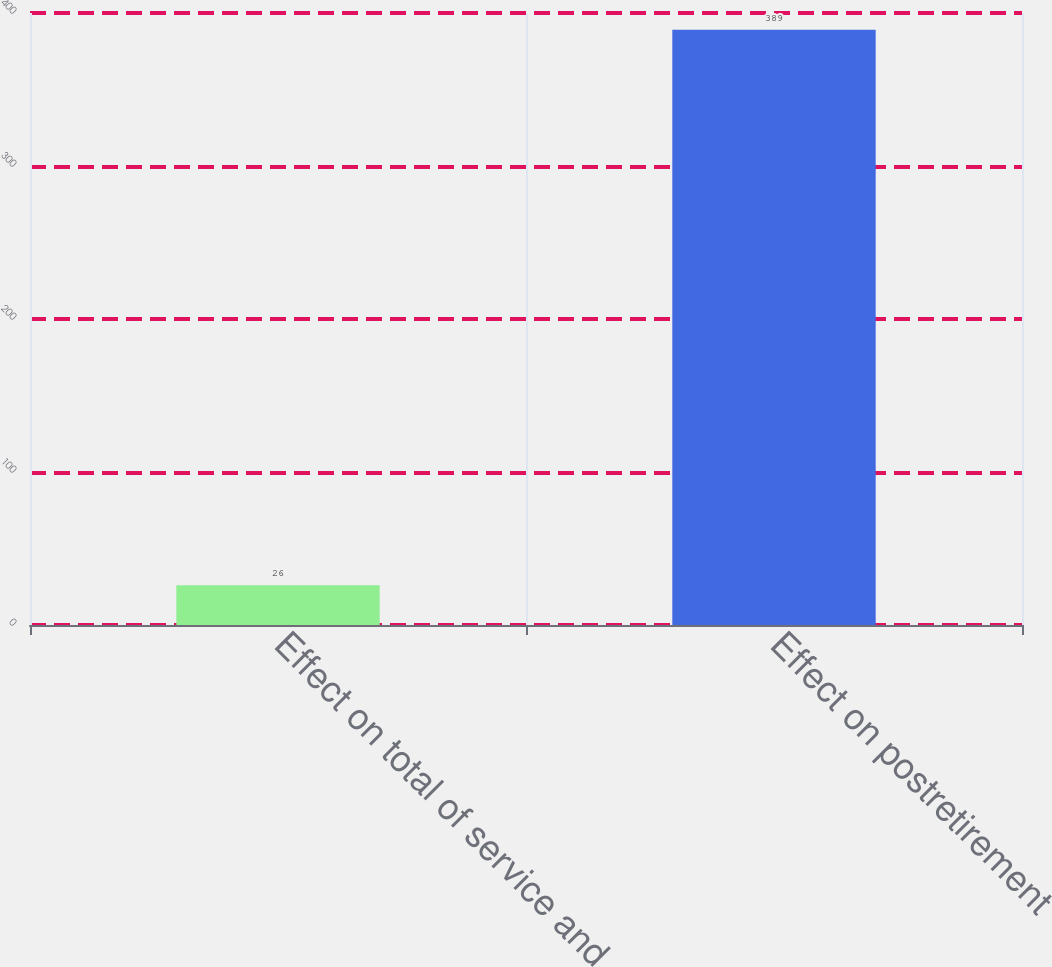Convert chart to OTSL. <chart><loc_0><loc_0><loc_500><loc_500><bar_chart><fcel>Effect on total of service and<fcel>Effect on postretirement<nl><fcel>26<fcel>389<nl></chart> 